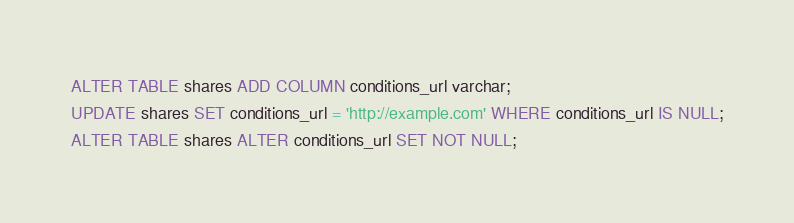<code> <loc_0><loc_0><loc_500><loc_500><_SQL_>ALTER TABLE shares ADD COLUMN conditions_url varchar;
UPDATE shares SET conditions_url = 'http://example.com' WHERE conditions_url IS NULL;
ALTER TABLE shares ALTER conditions_url SET NOT NULL;
</code> 